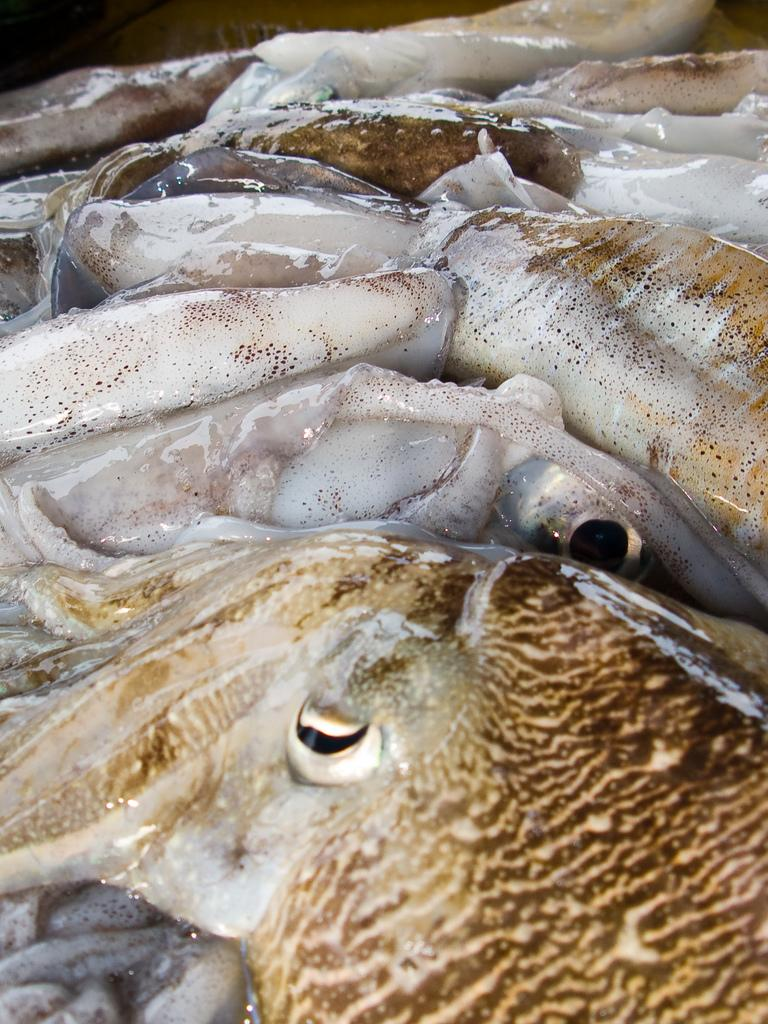What type of animals can be seen in the image? There are many fishes in the image. Where are the fishes located? The fishes are in the water. What type of farm can be seen in the image? There is no farm present in the image; it features many fishes in the water. What kind of car is visible in the image? There is no car present in the image; it only contains fishes in the water. 